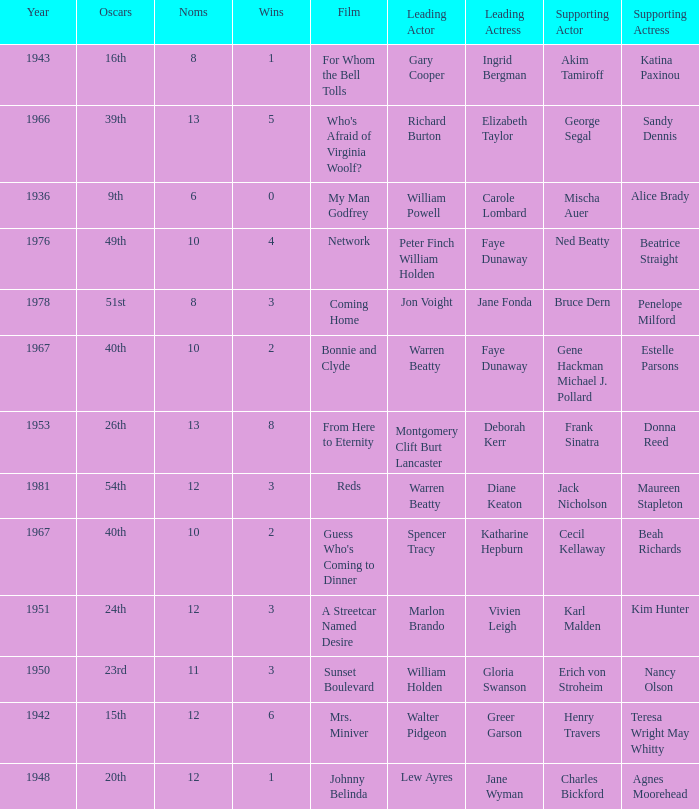Who was the leading actress in a film with Warren Beatty as the leading actor and also at the 40th Oscars? Faye Dunaway. 